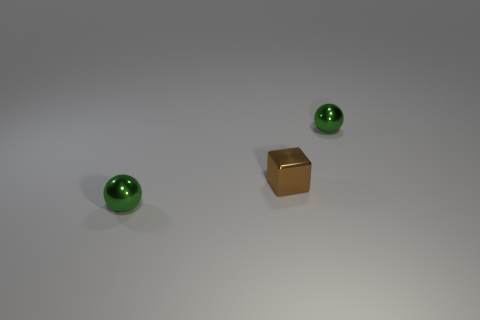Add 1 tiny brown cubes. How many objects exist? 4 Subtract all spheres. How many objects are left? 1 Add 3 green metallic balls. How many green metallic balls are left? 5 Add 2 green things. How many green things exist? 4 Subtract 0 cyan cylinders. How many objects are left? 3 Subtract all brown metallic blocks. Subtract all brown metal things. How many objects are left? 1 